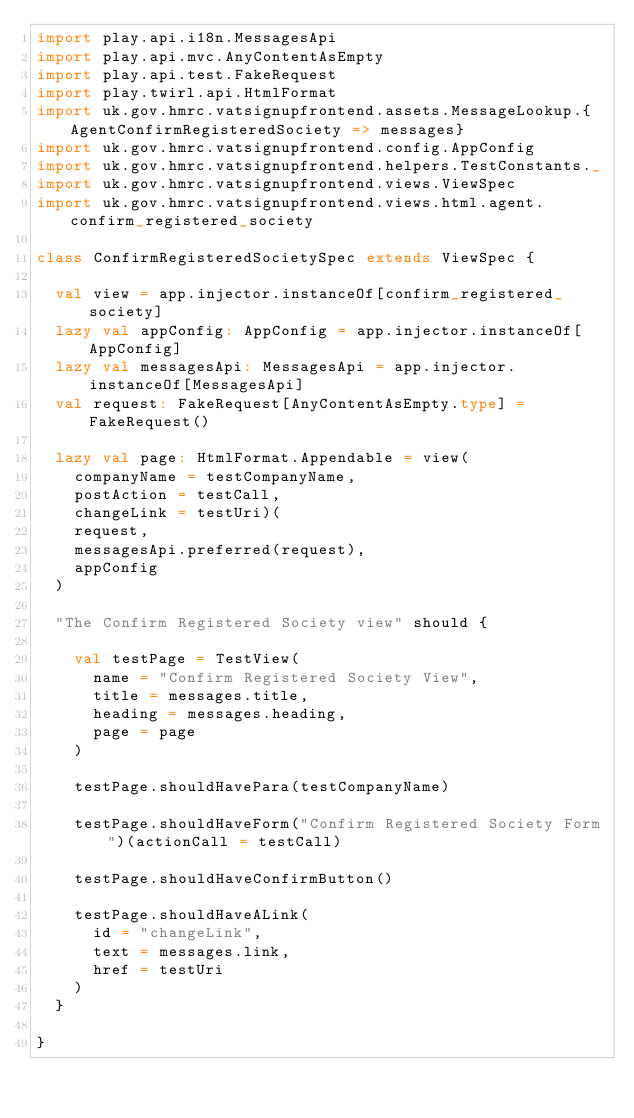Convert code to text. <code><loc_0><loc_0><loc_500><loc_500><_Scala_>import play.api.i18n.MessagesApi
import play.api.mvc.AnyContentAsEmpty
import play.api.test.FakeRequest
import play.twirl.api.HtmlFormat
import uk.gov.hmrc.vatsignupfrontend.assets.MessageLookup.{AgentConfirmRegisteredSociety => messages}
import uk.gov.hmrc.vatsignupfrontend.config.AppConfig
import uk.gov.hmrc.vatsignupfrontend.helpers.TestConstants._
import uk.gov.hmrc.vatsignupfrontend.views.ViewSpec
import uk.gov.hmrc.vatsignupfrontend.views.html.agent.confirm_registered_society

class ConfirmRegisteredSocietySpec extends ViewSpec {

  val view = app.injector.instanceOf[confirm_registered_society]
  lazy val appConfig: AppConfig = app.injector.instanceOf[AppConfig]
  lazy val messagesApi: MessagesApi = app.injector.instanceOf[MessagesApi]
  val request: FakeRequest[AnyContentAsEmpty.type] = FakeRequest()

  lazy val page: HtmlFormat.Appendable = view(
    companyName = testCompanyName,
    postAction = testCall,
    changeLink = testUri)(
    request,
    messagesApi.preferred(request),
    appConfig
  )

  "The Confirm Registered Society view" should {

    val testPage = TestView(
      name = "Confirm Registered Society View",
      title = messages.title,
      heading = messages.heading,
      page = page
    )

    testPage.shouldHavePara(testCompanyName)

    testPage.shouldHaveForm("Confirm Registered Society Form")(actionCall = testCall)

    testPage.shouldHaveConfirmButton()

    testPage.shouldHaveALink(
      id = "changeLink",
      text = messages.link,
      href = testUri
    )
  }

}

</code> 